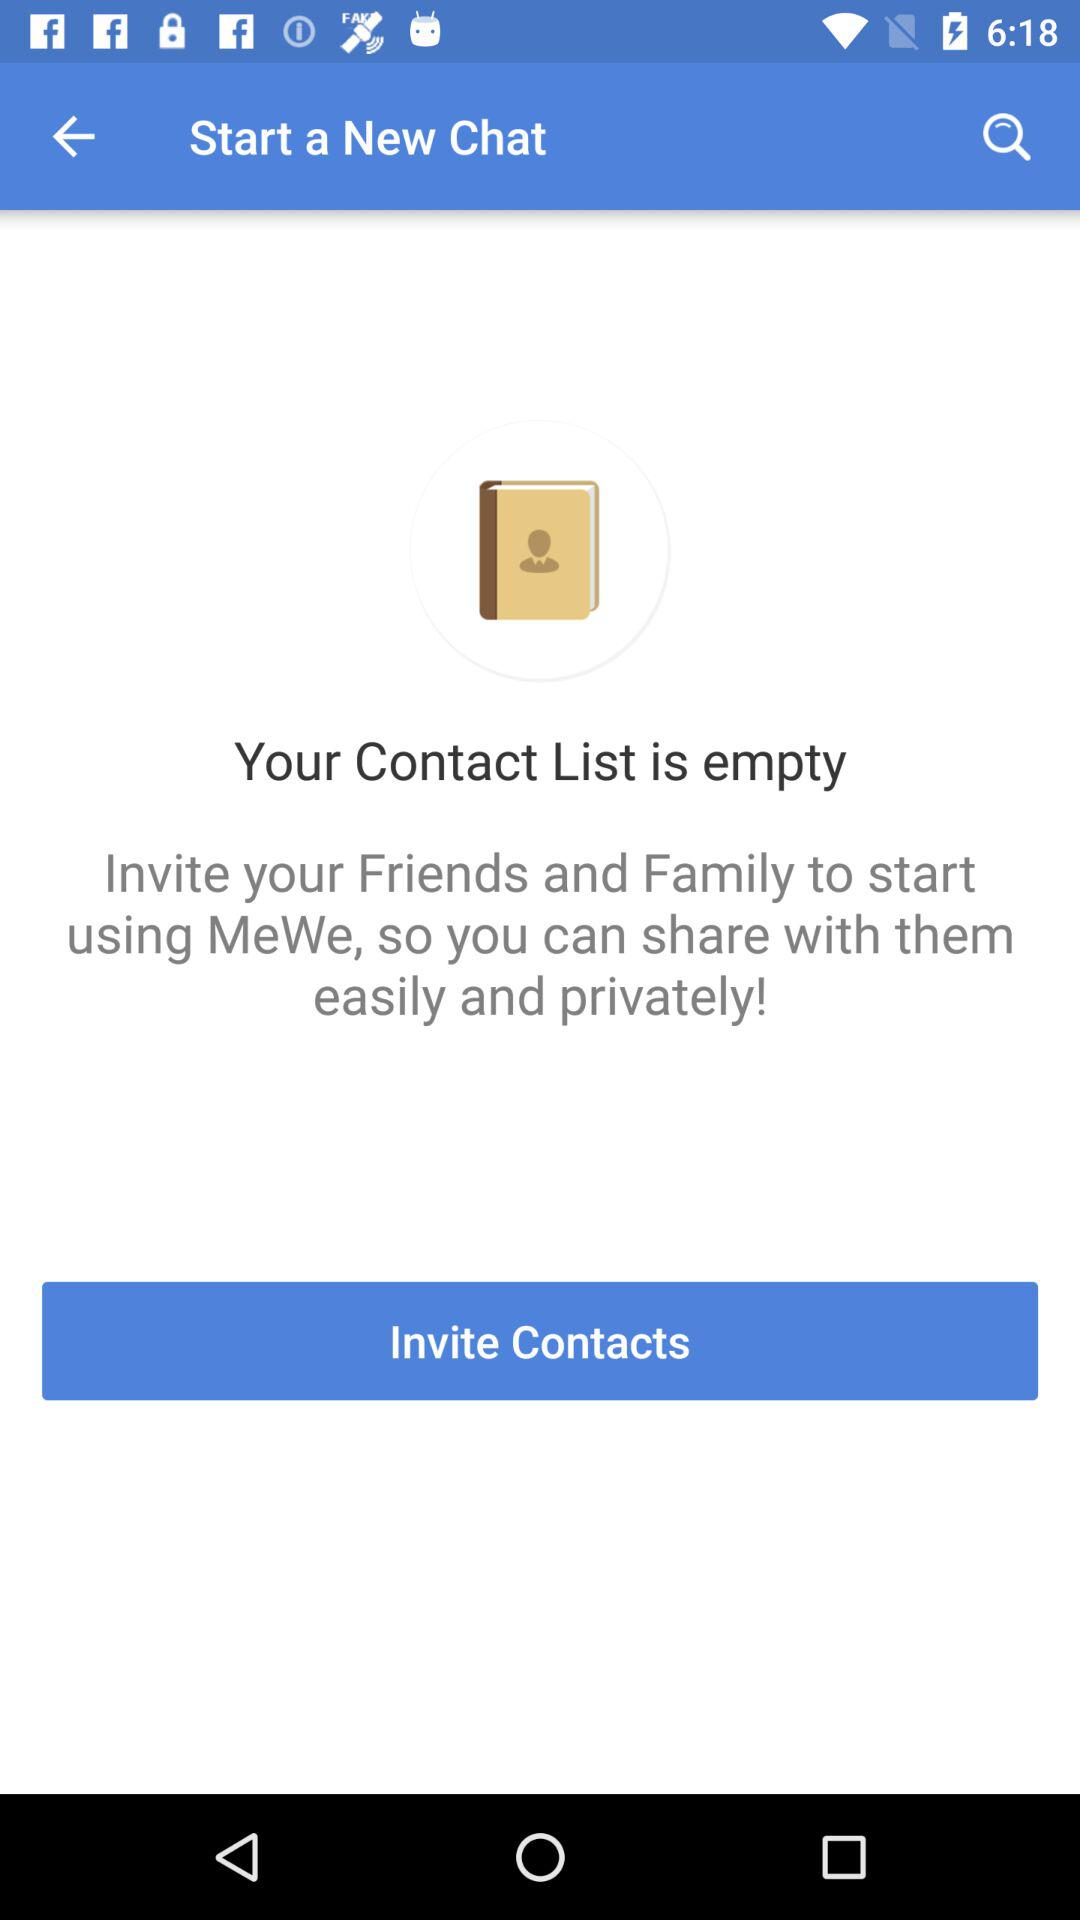What is the name of the application? The name of the application is "MeWe". 